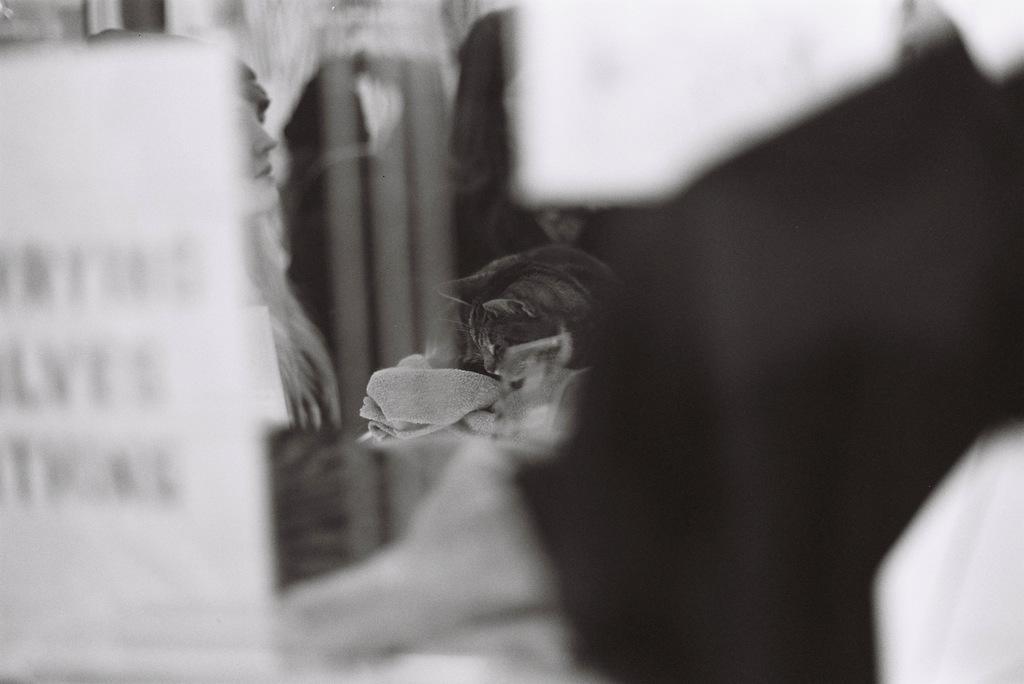What is the color scheme of the image? The image is black and white. Can you describe the main subject in the image? There is a person in the image. What else can be seen in the image besides the person? There is an object in the image. How would you describe the quality of the image? The corners and background of the image are blurred. What type of vein is visible on the person's arm in the image? There is no visible vein on the person's arm in the image, as it is a black and white image. Can you tell me how many cabbages are present in the image? There are no cabbages present in the image; it features a person and an object. 